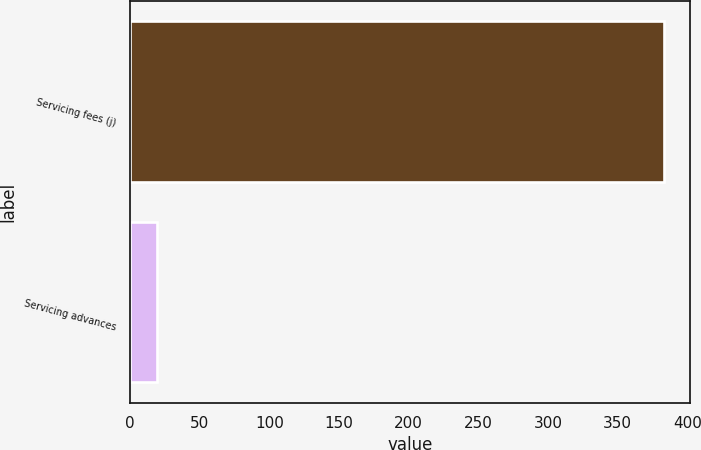Convert chart. <chart><loc_0><loc_0><loc_500><loc_500><bar_chart><fcel>Servicing fees (j)<fcel>Servicing advances<nl><fcel>383<fcel>19<nl></chart> 